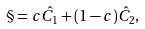<formula> <loc_0><loc_0><loc_500><loc_500>\S = c \hat { C _ { 1 } } + ( 1 - c ) \hat { C _ { 2 } } ,</formula> 